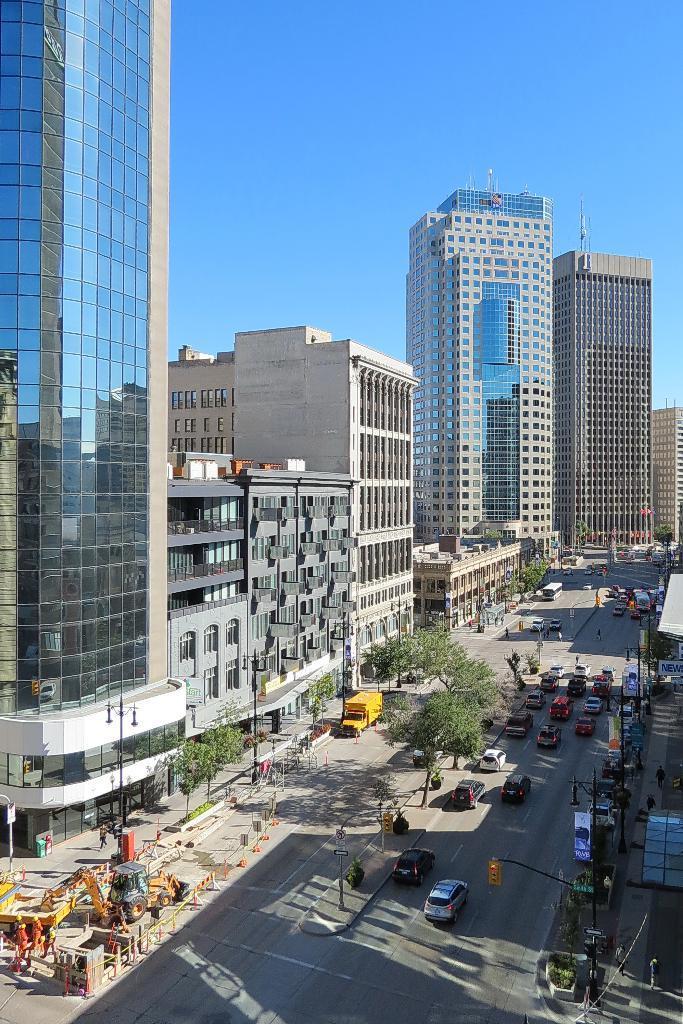Can you describe this image briefly? This is the picture of a city. In this image there are buildings and trees and poles and there are vehicles on the road. At the top there is sky. At the bottom there is a road and there are group of people on the footpath. 